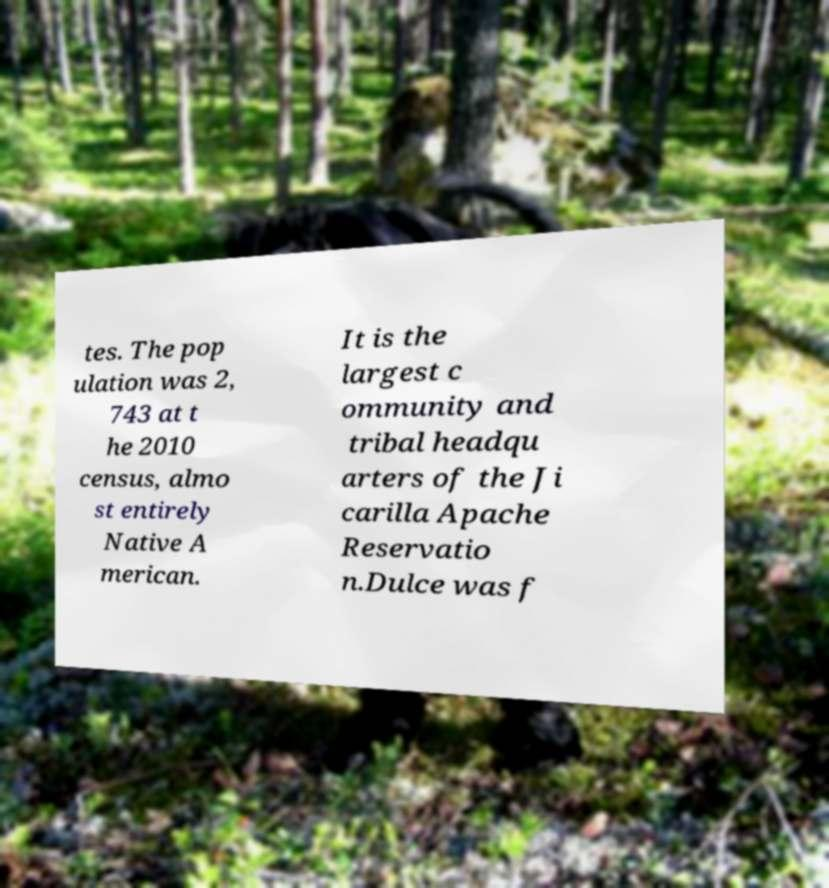Could you assist in decoding the text presented in this image and type it out clearly? tes. The pop ulation was 2, 743 at t he 2010 census, almo st entirely Native A merican. It is the largest c ommunity and tribal headqu arters of the Ji carilla Apache Reservatio n.Dulce was f 